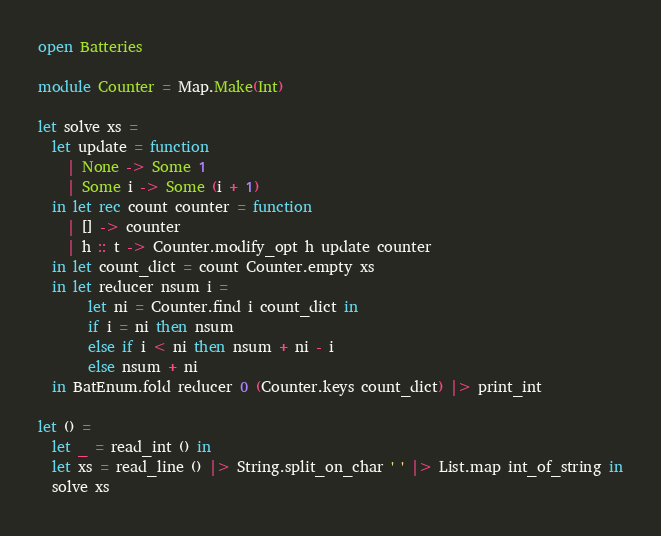Convert code to text. <code><loc_0><loc_0><loc_500><loc_500><_OCaml_>open Batteries

module Counter = Map.Make(Int)

let solve xs =
  let update = function
    | None -> Some 1
    | Some i -> Some (i + 1)
  in let rec count counter = function
    | [] -> counter
    | h :: t -> Counter.modify_opt h update counter
  in let count_dict = count Counter.empty xs
  in let reducer nsum i =
       let ni = Counter.find i count_dict in
       if i = ni then nsum
       else if i < ni then nsum + ni - i
       else nsum + ni
  in BatEnum.fold reducer 0 (Counter.keys count_dict) |> print_int

let () =
  let _ = read_int () in
  let xs = read_line () |> String.split_on_char ' ' |> List.map int_of_string in
  solve xs
</code> 